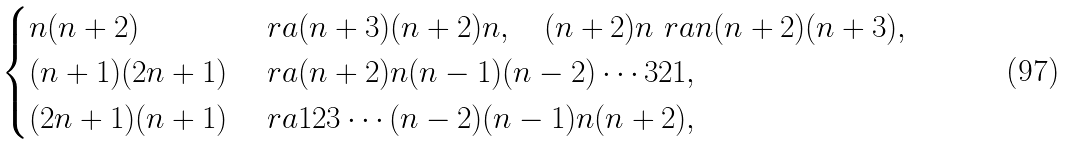Convert formula to latex. <formula><loc_0><loc_0><loc_500><loc_500>\begin{cases} n ( n + 2 ) & \ r a ( n + 3 ) ( n + 2 ) n , \quad ( n + 2 ) n \ r a n ( n + 2 ) ( n + 3 ) , \\ ( n + 1 ) ( 2 n + 1 ) & \ r a ( n + 2 ) n ( n - 1 ) ( n - 2 ) \cdots 3 2 1 , \\ ( 2 n + 1 ) ( n + 1 ) & \ r a 1 2 3 \cdots ( n - 2 ) ( n - 1 ) n ( n + 2 ) , \\ \end{cases}</formula> 